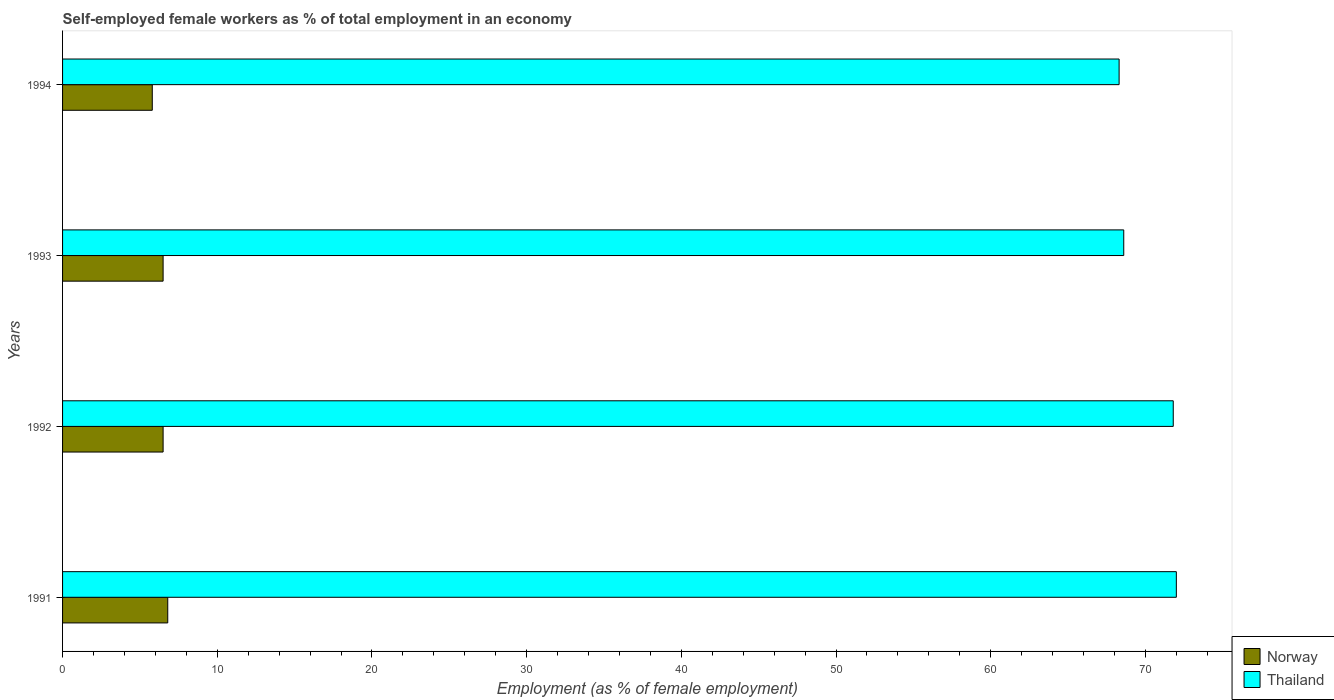How many groups of bars are there?
Ensure brevity in your answer.  4. What is the label of the 4th group of bars from the top?
Provide a succinct answer. 1991. In how many cases, is the number of bars for a given year not equal to the number of legend labels?
Give a very brief answer. 0. What is the percentage of self-employed female workers in Thailand in 1994?
Provide a short and direct response. 68.3. Across all years, what is the maximum percentage of self-employed female workers in Thailand?
Offer a very short reply. 72. Across all years, what is the minimum percentage of self-employed female workers in Thailand?
Your answer should be very brief. 68.3. In which year was the percentage of self-employed female workers in Thailand minimum?
Offer a very short reply. 1994. What is the total percentage of self-employed female workers in Norway in the graph?
Keep it short and to the point. 25.6. What is the difference between the percentage of self-employed female workers in Norway in 1991 and that in 1992?
Your answer should be very brief. 0.3. What is the difference between the percentage of self-employed female workers in Thailand in 1993 and the percentage of self-employed female workers in Norway in 1991?
Your answer should be compact. 61.8. What is the average percentage of self-employed female workers in Thailand per year?
Your answer should be compact. 70.18. In the year 1994, what is the difference between the percentage of self-employed female workers in Norway and percentage of self-employed female workers in Thailand?
Provide a succinct answer. -62.5. What is the ratio of the percentage of self-employed female workers in Norway in 1991 to that in 1992?
Your answer should be compact. 1.05. What is the difference between the highest and the second highest percentage of self-employed female workers in Norway?
Keep it short and to the point. 0.3. In how many years, is the percentage of self-employed female workers in Thailand greater than the average percentage of self-employed female workers in Thailand taken over all years?
Offer a terse response. 2. Is the sum of the percentage of self-employed female workers in Norway in 1992 and 1994 greater than the maximum percentage of self-employed female workers in Thailand across all years?
Offer a terse response. No. What does the 1st bar from the top in 1992 represents?
Your response must be concise. Thailand. What does the 1st bar from the bottom in 1992 represents?
Ensure brevity in your answer.  Norway. How many bars are there?
Provide a short and direct response. 8. What is the difference between two consecutive major ticks on the X-axis?
Your answer should be compact. 10. Does the graph contain grids?
Your answer should be very brief. No. How are the legend labels stacked?
Offer a very short reply. Vertical. What is the title of the graph?
Make the answer very short. Self-employed female workers as % of total employment in an economy. What is the label or title of the X-axis?
Ensure brevity in your answer.  Employment (as % of female employment). What is the Employment (as % of female employment) in Norway in 1991?
Ensure brevity in your answer.  6.8. What is the Employment (as % of female employment) of Thailand in 1991?
Your answer should be very brief. 72. What is the Employment (as % of female employment) in Norway in 1992?
Offer a very short reply. 6.5. What is the Employment (as % of female employment) of Thailand in 1992?
Make the answer very short. 71.8. What is the Employment (as % of female employment) in Thailand in 1993?
Make the answer very short. 68.6. What is the Employment (as % of female employment) in Norway in 1994?
Give a very brief answer. 5.8. What is the Employment (as % of female employment) in Thailand in 1994?
Provide a short and direct response. 68.3. Across all years, what is the maximum Employment (as % of female employment) in Norway?
Give a very brief answer. 6.8. Across all years, what is the minimum Employment (as % of female employment) of Norway?
Your answer should be very brief. 5.8. Across all years, what is the minimum Employment (as % of female employment) of Thailand?
Offer a terse response. 68.3. What is the total Employment (as % of female employment) of Norway in the graph?
Ensure brevity in your answer.  25.6. What is the total Employment (as % of female employment) of Thailand in the graph?
Your response must be concise. 280.7. What is the difference between the Employment (as % of female employment) in Thailand in 1991 and that in 1992?
Your answer should be very brief. 0.2. What is the difference between the Employment (as % of female employment) of Norway in 1991 and that in 1993?
Keep it short and to the point. 0.3. What is the difference between the Employment (as % of female employment) in Thailand in 1991 and that in 1993?
Offer a terse response. 3.4. What is the difference between the Employment (as % of female employment) of Thailand in 1991 and that in 1994?
Make the answer very short. 3.7. What is the difference between the Employment (as % of female employment) in Norway in 1992 and that in 1994?
Offer a terse response. 0.7. What is the difference between the Employment (as % of female employment) in Norway in 1991 and the Employment (as % of female employment) in Thailand in 1992?
Keep it short and to the point. -65. What is the difference between the Employment (as % of female employment) of Norway in 1991 and the Employment (as % of female employment) of Thailand in 1993?
Offer a very short reply. -61.8. What is the difference between the Employment (as % of female employment) in Norway in 1991 and the Employment (as % of female employment) in Thailand in 1994?
Offer a very short reply. -61.5. What is the difference between the Employment (as % of female employment) in Norway in 1992 and the Employment (as % of female employment) in Thailand in 1993?
Your answer should be very brief. -62.1. What is the difference between the Employment (as % of female employment) in Norway in 1992 and the Employment (as % of female employment) in Thailand in 1994?
Offer a terse response. -61.8. What is the difference between the Employment (as % of female employment) of Norway in 1993 and the Employment (as % of female employment) of Thailand in 1994?
Make the answer very short. -61.8. What is the average Employment (as % of female employment) in Norway per year?
Your response must be concise. 6.4. What is the average Employment (as % of female employment) of Thailand per year?
Offer a very short reply. 70.17. In the year 1991, what is the difference between the Employment (as % of female employment) in Norway and Employment (as % of female employment) in Thailand?
Provide a short and direct response. -65.2. In the year 1992, what is the difference between the Employment (as % of female employment) in Norway and Employment (as % of female employment) in Thailand?
Give a very brief answer. -65.3. In the year 1993, what is the difference between the Employment (as % of female employment) of Norway and Employment (as % of female employment) of Thailand?
Provide a short and direct response. -62.1. In the year 1994, what is the difference between the Employment (as % of female employment) in Norway and Employment (as % of female employment) in Thailand?
Provide a succinct answer. -62.5. What is the ratio of the Employment (as % of female employment) in Norway in 1991 to that in 1992?
Give a very brief answer. 1.05. What is the ratio of the Employment (as % of female employment) of Norway in 1991 to that in 1993?
Offer a very short reply. 1.05. What is the ratio of the Employment (as % of female employment) in Thailand in 1991 to that in 1993?
Keep it short and to the point. 1.05. What is the ratio of the Employment (as % of female employment) of Norway in 1991 to that in 1994?
Offer a very short reply. 1.17. What is the ratio of the Employment (as % of female employment) of Thailand in 1991 to that in 1994?
Offer a terse response. 1.05. What is the ratio of the Employment (as % of female employment) in Norway in 1992 to that in 1993?
Your answer should be compact. 1. What is the ratio of the Employment (as % of female employment) of Thailand in 1992 to that in 1993?
Your answer should be compact. 1.05. What is the ratio of the Employment (as % of female employment) of Norway in 1992 to that in 1994?
Your answer should be very brief. 1.12. What is the ratio of the Employment (as % of female employment) of Thailand in 1992 to that in 1994?
Ensure brevity in your answer.  1.05. What is the ratio of the Employment (as % of female employment) of Norway in 1993 to that in 1994?
Keep it short and to the point. 1.12. What is the ratio of the Employment (as % of female employment) of Thailand in 1993 to that in 1994?
Give a very brief answer. 1. What is the difference between the highest and the second highest Employment (as % of female employment) in Thailand?
Your answer should be compact. 0.2. What is the difference between the highest and the lowest Employment (as % of female employment) in Norway?
Give a very brief answer. 1. What is the difference between the highest and the lowest Employment (as % of female employment) of Thailand?
Offer a very short reply. 3.7. 